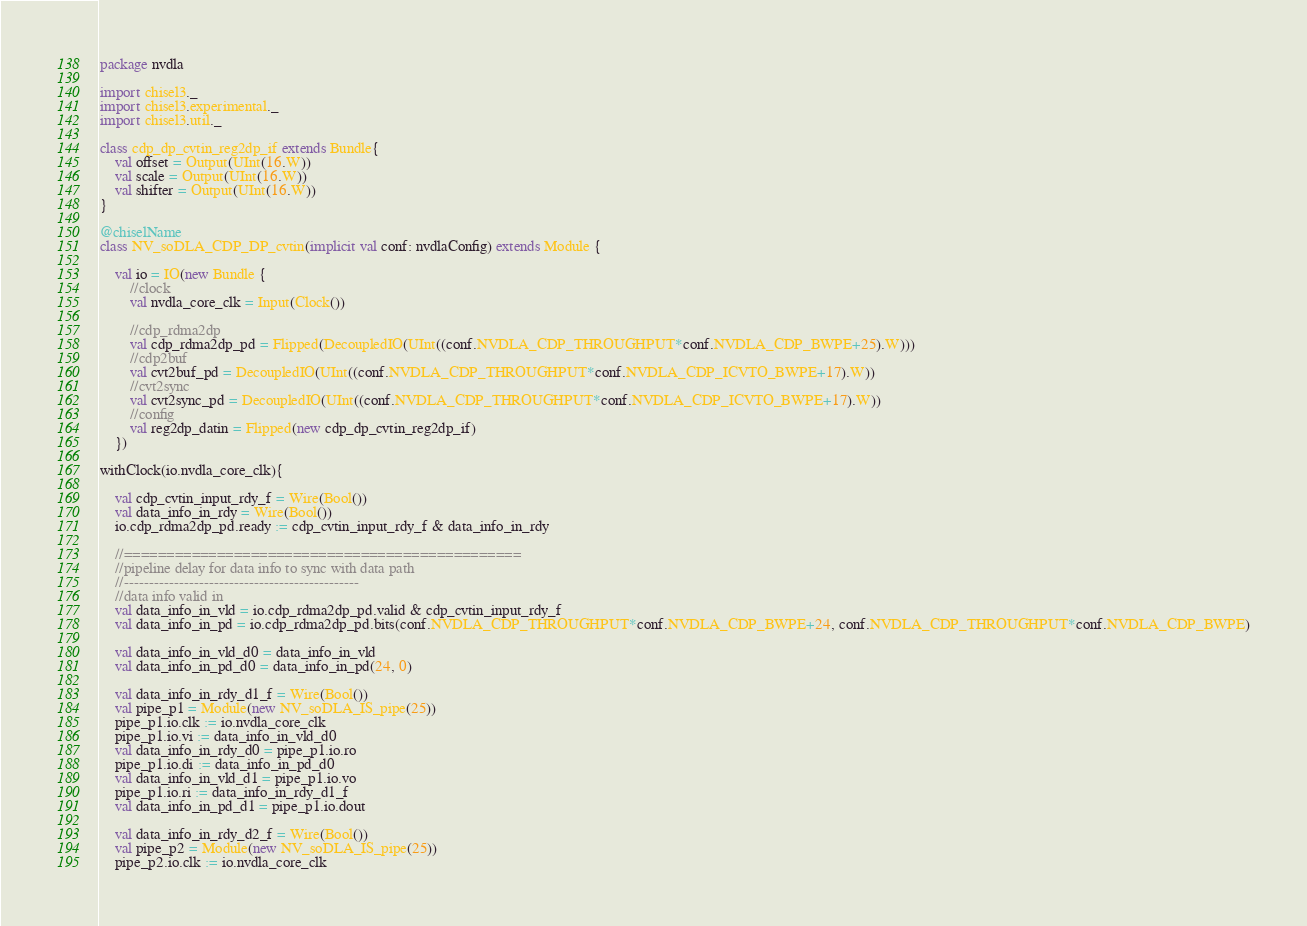Convert code to text. <code><loc_0><loc_0><loc_500><loc_500><_Scala_>package nvdla

import chisel3._
import chisel3.experimental._
import chisel3.util._

class cdp_dp_cvtin_reg2dp_if extends Bundle{
    val offset = Output(UInt(16.W))
    val scale = Output(UInt(16.W))
    val shifter = Output(UInt(16.W))
}

@chiselName
class NV_soDLA_CDP_DP_cvtin(implicit val conf: nvdlaConfig) extends Module {

    val io = IO(new Bundle {
        //clock
        val nvdla_core_clk = Input(Clock())

        //cdp_rdma2dp
        val cdp_rdma2dp_pd = Flipped(DecoupledIO(UInt((conf.NVDLA_CDP_THROUGHPUT*conf.NVDLA_CDP_BWPE+25).W)))
        //cdp2buf
        val cvt2buf_pd = DecoupledIO(UInt((conf.NVDLA_CDP_THROUGHPUT*conf.NVDLA_CDP_ICVTO_BWPE+17).W))
        //cvt2sync
        val cvt2sync_pd = DecoupledIO(UInt((conf.NVDLA_CDP_THROUGHPUT*conf.NVDLA_CDP_ICVTO_BWPE+17).W))
        //config
        val reg2dp_datin = Flipped(new cdp_dp_cvtin_reg2dp_if)
    })

withClock(io.nvdla_core_clk){

    val cdp_cvtin_input_rdy_f = Wire(Bool())
    val data_info_in_rdy = Wire(Bool())
    io.cdp_rdma2dp_pd.ready := cdp_cvtin_input_rdy_f & data_info_in_rdy

    //===============================================
    //pipeline delay for data info to sync with data path
    //-----------------------------------------------
    //data info valid in
    val data_info_in_vld = io.cdp_rdma2dp_pd.valid & cdp_cvtin_input_rdy_f
    val data_info_in_pd = io.cdp_rdma2dp_pd.bits(conf.NVDLA_CDP_THROUGHPUT*conf.NVDLA_CDP_BWPE+24, conf.NVDLA_CDP_THROUGHPUT*conf.NVDLA_CDP_BWPE)

    val data_info_in_vld_d0 = data_info_in_vld
    val data_info_in_pd_d0 = data_info_in_pd(24, 0)

    val data_info_in_rdy_d1_f = Wire(Bool())
    val pipe_p1 = Module(new NV_soDLA_IS_pipe(25))
    pipe_p1.io.clk := io.nvdla_core_clk
    pipe_p1.io.vi := data_info_in_vld_d0
    val data_info_in_rdy_d0 = pipe_p1.io.ro
    pipe_p1.io.di := data_info_in_pd_d0
    val data_info_in_vld_d1 = pipe_p1.io.vo
    pipe_p1.io.ri := data_info_in_rdy_d1_f
    val data_info_in_pd_d1 = pipe_p1.io.dout

    val data_info_in_rdy_d2_f = Wire(Bool())
    val pipe_p2 = Module(new NV_soDLA_IS_pipe(25))
    pipe_p2.io.clk := io.nvdla_core_clk</code> 